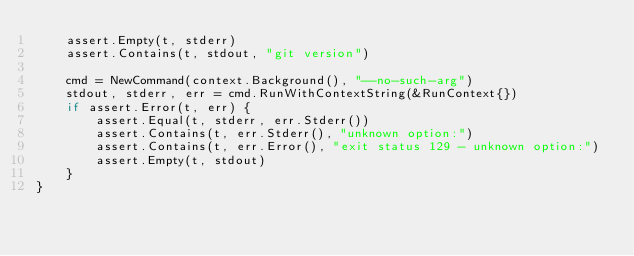<code> <loc_0><loc_0><loc_500><loc_500><_Go_>	assert.Empty(t, stderr)
	assert.Contains(t, stdout, "git version")

	cmd = NewCommand(context.Background(), "--no-such-arg")
	stdout, stderr, err = cmd.RunWithContextString(&RunContext{})
	if assert.Error(t, err) {
		assert.Equal(t, stderr, err.Stderr())
		assert.Contains(t, err.Stderr(), "unknown option:")
		assert.Contains(t, err.Error(), "exit status 129 - unknown option:")
		assert.Empty(t, stdout)
	}
}
</code> 